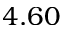<formula> <loc_0><loc_0><loc_500><loc_500>4 . 6 0</formula> 